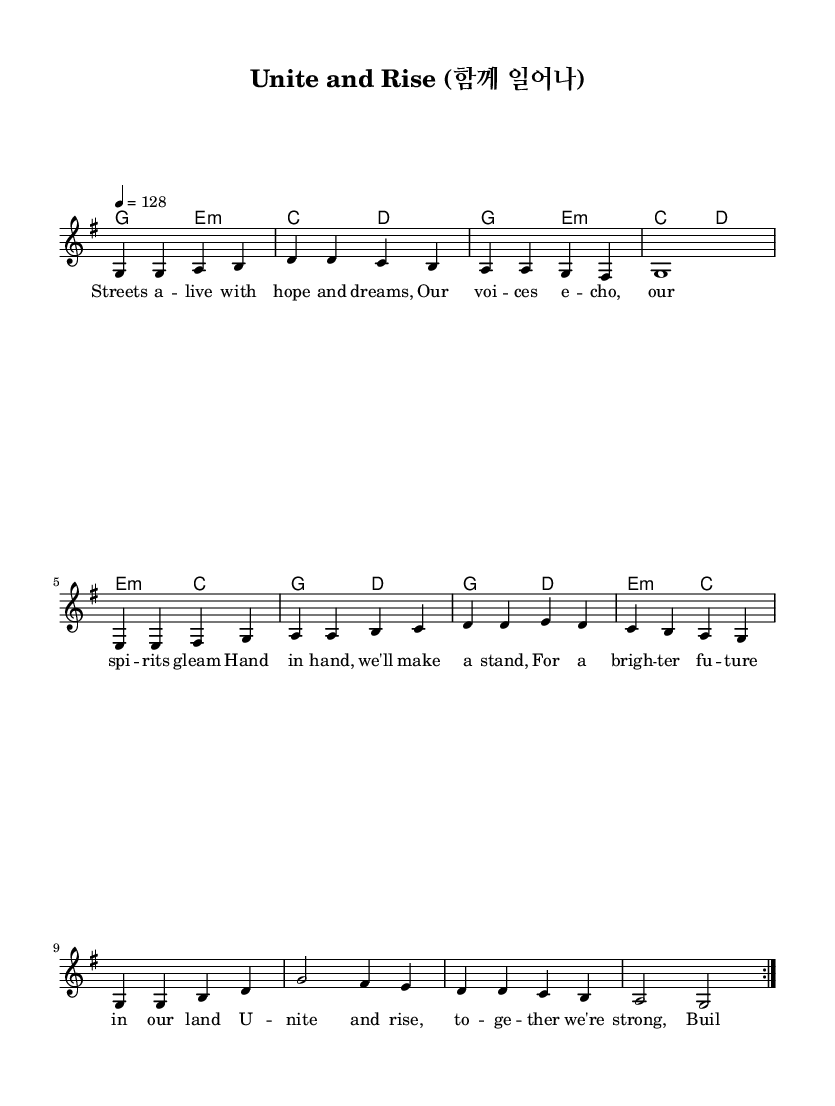What is the key signature of this music? The key signature is G major, which has one sharp (F#). This can be determined by looking at the beginning of the sheet music, where the key signature is indicated.
Answer: G major What is the time signature of this music? The time signature is 4/4, which indicates there are four beats in each measure and the quarter note gets one beat. This is visually represented at the beginning of the staff.
Answer: 4/4 What is the tempo marking for this piece? The tempo marking is 128 beats per minute, indicated at the start of the music. This specifies how fast the piece should be played.
Answer: 128 How many verses are there in the melody section? There are two verses in the melody section, as indicated by the "repeat volta 2" marking, which shows that the melody should be played twice.
Answer: 2 What themes are present in the lyrics? The lyrics focus on community engagement and social change, with phrases suggesting unity, hope, and building a better future. This thematic content is evident in the lyrics themselves.
Answer: Community engagement What type of chord progression is used throughout the piece? The progression primarily uses common pop chord changes such as G, E minor, and C, which are typical in K-Pop. By examining the harmony section, we can see the chords move in a familiar sequence.
Answer: Common pop progression What is the main message of the song as reflected in the lyrics? The main message is about unity and the strength of coming together to create change. This is derived from lines advocating for standing together for a brighter future and building bridges.
Answer: Unity and social change 